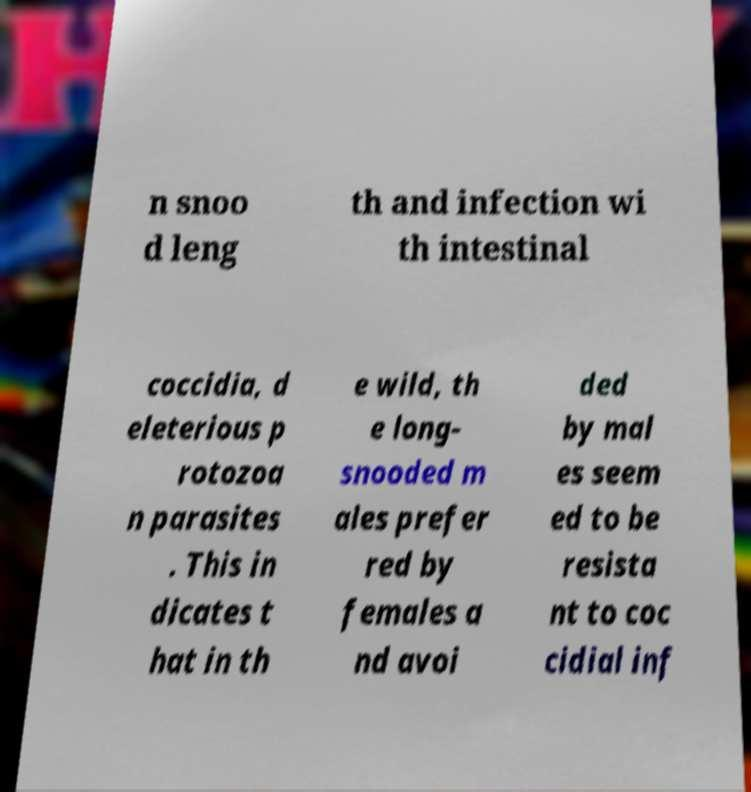What messages or text are displayed in this image? I need them in a readable, typed format. n snoo d leng th and infection wi th intestinal coccidia, d eleterious p rotozoa n parasites . This in dicates t hat in th e wild, th e long- snooded m ales prefer red by females a nd avoi ded by mal es seem ed to be resista nt to coc cidial inf 